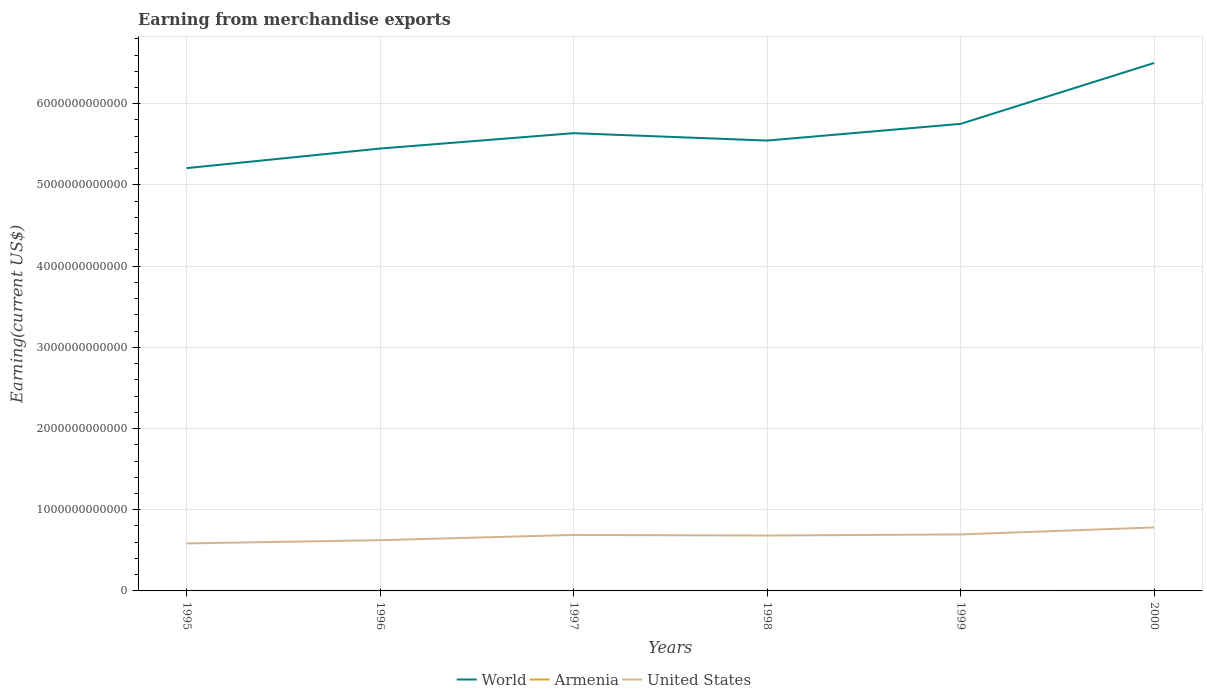Does the line corresponding to World intersect with the line corresponding to United States?
Keep it short and to the point. No. Is the number of lines equal to the number of legend labels?
Provide a succinct answer. Yes. Across all years, what is the maximum amount earned from merchandise exports in United States?
Provide a short and direct response. 5.85e+11. What is the total amount earned from merchandise exports in World in the graph?
Make the answer very short. -7.50e+11. What is the difference between the highest and the second highest amount earned from merchandise exports in World?
Your response must be concise. 1.29e+12. How many lines are there?
Provide a succinct answer. 3. How many years are there in the graph?
Provide a succinct answer. 6. What is the difference between two consecutive major ticks on the Y-axis?
Give a very brief answer. 1.00e+12. Does the graph contain any zero values?
Provide a short and direct response. No. Does the graph contain grids?
Offer a terse response. Yes. How are the legend labels stacked?
Your answer should be very brief. Horizontal. What is the title of the graph?
Your answer should be very brief. Earning from merchandise exports. Does "Comoros" appear as one of the legend labels in the graph?
Make the answer very short. No. What is the label or title of the Y-axis?
Provide a succinct answer. Earning(current US$). What is the Earning(current US$) of World in 1995?
Your response must be concise. 5.21e+12. What is the Earning(current US$) in Armenia in 1995?
Ensure brevity in your answer.  2.71e+08. What is the Earning(current US$) in United States in 1995?
Provide a short and direct response. 5.85e+11. What is the Earning(current US$) in World in 1996?
Give a very brief answer. 5.45e+12. What is the Earning(current US$) in Armenia in 1996?
Your response must be concise. 2.90e+08. What is the Earning(current US$) of United States in 1996?
Your answer should be very brief. 6.25e+11. What is the Earning(current US$) in World in 1997?
Provide a short and direct response. 5.64e+12. What is the Earning(current US$) in Armenia in 1997?
Your response must be concise. 2.33e+08. What is the Earning(current US$) of United States in 1997?
Your answer should be compact. 6.89e+11. What is the Earning(current US$) in World in 1998?
Ensure brevity in your answer.  5.55e+12. What is the Earning(current US$) in Armenia in 1998?
Offer a very short reply. 2.21e+08. What is the Earning(current US$) in United States in 1998?
Your answer should be very brief. 6.82e+11. What is the Earning(current US$) in World in 1999?
Provide a succinct answer. 5.75e+12. What is the Earning(current US$) in Armenia in 1999?
Offer a terse response. 2.32e+08. What is the Earning(current US$) in United States in 1999?
Keep it short and to the point. 6.96e+11. What is the Earning(current US$) of World in 2000?
Ensure brevity in your answer.  6.50e+12. What is the Earning(current US$) in Armenia in 2000?
Your answer should be very brief. 2.94e+08. What is the Earning(current US$) in United States in 2000?
Offer a terse response. 7.82e+11. Across all years, what is the maximum Earning(current US$) of World?
Keep it short and to the point. 6.50e+12. Across all years, what is the maximum Earning(current US$) of Armenia?
Make the answer very short. 2.94e+08. Across all years, what is the maximum Earning(current US$) in United States?
Give a very brief answer. 7.82e+11. Across all years, what is the minimum Earning(current US$) in World?
Provide a short and direct response. 5.21e+12. Across all years, what is the minimum Earning(current US$) in Armenia?
Your answer should be compact. 2.21e+08. Across all years, what is the minimum Earning(current US$) in United States?
Your response must be concise. 5.85e+11. What is the total Earning(current US$) of World in the graph?
Your answer should be compact. 3.41e+13. What is the total Earning(current US$) of Armenia in the graph?
Your answer should be compact. 1.54e+09. What is the total Earning(current US$) of United States in the graph?
Offer a terse response. 4.06e+12. What is the difference between the Earning(current US$) of World in 1995 and that in 1996?
Offer a terse response. -2.41e+11. What is the difference between the Earning(current US$) in Armenia in 1995 and that in 1996?
Ensure brevity in your answer.  -1.90e+07. What is the difference between the Earning(current US$) of United States in 1995 and that in 1996?
Give a very brief answer. -4.03e+1. What is the difference between the Earning(current US$) of World in 1995 and that in 1997?
Your response must be concise. -4.30e+11. What is the difference between the Earning(current US$) of Armenia in 1995 and that in 1997?
Provide a succinct answer. 3.80e+07. What is the difference between the Earning(current US$) in United States in 1995 and that in 1997?
Your answer should be very brief. -1.04e+11. What is the difference between the Earning(current US$) in World in 1995 and that in 1998?
Your answer should be very brief. -3.39e+11. What is the difference between the Earning(current US$) in United States in 1995 and that in 1998?
Offer a terse response. -9.74e+1. What is the difference between the Earning(current US$) in World in 1995 and that in 1999?
Your answer should be compact. -5.45e+11. What is the difference between the Earning(current US$) of Armenia in 1995 and that in 1999?
Keep it short and to the point. 3.90e+07. What is the difference between the Earning(current US$) in United States in 1995 and that in 1999?
Make the answer very short. -1.11e+11. What is the difference between the Earning(current US$) in World in 1995 and that in 2000?
Offer a terse response. -1.29e+12. What is the difference between the Earning(current US$) in Armenia in 1995 and that in 2000?
Offer a terse response. -2.30e+07. What is the difference between the Earning(current US$) in United States in 1995 and that in 2000?
Your answer should be compact. -1.97e+11. What is the difference between the Earning(current US$) of World in 1996 and that in 1997?
Make the answer very short. -1.89e+11. What is the difference between the Earning(current US$) of Armenia in 1996 and that in 1997?
Offer a terse response. 5.70e+07. What is the difference between the Earning(current US$) of United States in 1996 and that in 1997?
Ensure brevity in your answer.  -6.41e+1. What is the difference between the Earning(current US$) of World in 1996 and that in 1998?
Your answer should be very brief. -9.83e+1. What is the difference between the Earning(current US$) in Armenia in 1996 and that in 1998?
Offer a terse response. 6.90e+07. What is the difference between the Earning(current US$) of United States in 1996 and that in 1998?
Your response must be concise. -5.71e+1. What is the difference between the Earning(current US$) in World in 1996 and that in 1999?
Provide a short and direct response. -3.04e+11. What is the difference between the Earning(current US$) in Armenia in 1996 and that in 1999?
Provide a succinct answer. 5.80e+07. What is the difference between the Earning(current US$) of United States in 1996 and that in 1999?
Provide a succinct answer. -7.07e+1. What is the difference between the Earning(current US$) of World in 1996 and that in 2000?
Make the answer very short. -1.05e+12. What is the difference between the Earning(current US$) in United States in 1996 and that in 2000?
Offer a terse response. -1.57e+11. What is the difference between the Earning(current US$) of World in 1997 and that in 1998?
Offer a very short reply. 9.09e+1. What is the difference between the Earning(current US$) in Armenia in 1997 and that in 1998?
Keep it short and to the point. 1.20e+07. What is the difference between the Earning(current US$) of United States in 1997 and that in 1998?
Give a very brief answer. 7.04e+09. What is the difference between the Earning(current US$) in World in 1997 and that in 1999?
Your response must be concise. -1.15e+11. What is the difference between the Earning(current US$) in Armenia in 1997 and that in 1999?
Your answer should be very brief. 1.00e+06. What is the difference between the Earning(current US$) of United States in 1997 and that in 1999?
Your response must be concise. -6.62e+09. What is the difference between the Earning(current US$) in World in 1997 and that in 2000?
Your answer should be very brief. -8.65e+11. What is the difference between the Earning(current US$) in Armenia in 1997 and that in 2000?
Make the answer very short. -6.10e+07. What is the difference between the Earning(current US$) in United States in 1997 and that in 2000?
Make the answer very short. -9.27e+1. What is the difference between the Earning(current US$) in World in 1998 and that in 1999?
Give a very brief answer. -2.06e+11. What is the difference between the Earning(current US$) of Armenia in 1998 and that in 1999?
Provide a succinct answer. -1.10e+07. What is the difference between the Earning(current US$) of United States in 1998 and that in 1999?
Your answer should be very brief. -1.37e+1. What is the difference between the Earning(current US$) in World in 1998 and that in 2000?
Ensure brevity in your answer.  -9.56e+11. What is the difference between the Earning(current US$) of Armenia in 1998 and that in 2000?
Provide a short and direct response. -7.30e+07. What is the difference between the Earning(current US$) of United States in 1998 and that in 2000?
Your response must be concise. -9.98e+1. What is the difference between the Earning(current US$) in World in 1999 and that in 2000?
Offer a terse response. -7.50e+11. What is the difference between the Earning(current US$) of Armenia in 1999 and that in 2000?
Offer a very short reply. -6.20e+07. What is the difference between the Earning(current US$) in United States in 1999 and that in 2000?
Your response must be concise. -8.61e+1. What is the difference between the Earning(current US$) in World in 1995 and the Earning(current US$) in Armenia in 1996?
Make the answer very short. 5.21e+12. What is the difference between the Earning(current US$) in World in 1995 and the Earning(current US$) in United States in 1996?
Make the answer very short. 4.58e+12. What is the difference between the Earning(current US$) in Armenia in 1995 and the Earning(current US$) in United States in 1996?
Your answer should be very brief. -6.25e+11. What is the difference between the Earning(current US$) of World in 1995 and the Earning(current US$) of Armenia in 1997?
Offer a terse response. 5.21e+12. What is the difference between the Earning(current US$) of World in 1995 and the Earning(current US$) of United States in 1997?
Your answer should be very brief. 4.52e+12. What is the difference between the Earning(current US$) in Armenia in 1995 and the Earning(current US$) in United States in 1997?
Keep it short and to the point. -6.89e+11. What is the difference between the Earning(current US$) of World in 1995 and the Earning(current US$) of Armenia in 1998?
Offer a very short reply. 5.21e+12. What is the difference between the Earning(current US$) in World in 1995 and the Earning(current US$) in United States in 1998?
Offer a terse response. 4.52e+12. What is the difference between the Earning(current US$) of Armenia in 1995 and the Earning(current US$) of United States in 1998?
Your answer should be compact. -6.82e+11. What is the difference between the Earning(current US$) of World in 1995 and the Earning(current US$) of Armenia in 1999?
Provide a succinct answer. 5.21e+12. What is the difference between the Earning(current US$) of World in 1995 and the Earning(current US$) of United States in 1999?
Offer a terse response. 4.51e+12. What is the difference between the Earning(current US$) of Armenia in 1995 and the Earning(current US$) of United States in 1999?
Give a very brief answer. -6.96e+11. What is the difference between the Earning(current US$) in World in 1995 and the Earning(current US$) in Armenia in 2000?
Your answer should be very brief. 5.21e+12. What is the difference between the Earning(current US$) in World in 1995 and the Earning(current US$) in United States in 2000?
Give a very brief answer. 4.42e+12. What is the difference between the Earning(current US$) of Armenia in 1995 and the Earning(current US$) of United States in 2000?
Your response must be concise. -7.82e+11. What is the difference between the Earning(current US$) of World in 1996 and the Earning(current US$) of Armenia in 1997?
Keep it short and to the point. 5.45e+12. What is the difference between the Earning(current US$) of World in 1996 and the Earning(current US$) of United States in 1997?
Offer a very short reply. 4.76e+12. What is the difference between the Earning(current US$) of Armenia in 1996 and the Earning(current US$) of United States in 1997?
Offer a very short reply. -6.89e+11. What is the difference between the Earning(current US$) of World in 1996 and the Earning(current US$) of Armenia in 1998?
Keep it short and to the point. 5.45e+12. What is the difference between the Earning(current US$) in World in 1996 and the Earning(current US$) in United States in 1998?
Provide a succinct answer. 4.77e+12. What is the difference between the Earning(current US$) of Armenia in 1996 and the Earning(current US$) of United States in 1998?
Provide a short and direct response. -6.82e+11. What is the difference between the Earning(current US$) in World in 1996 and the Earning(current US$) in Armenia in 1999?
Keep it short and to the point. 5.45e+12. What is the difference between the Earning(current US$) in World in 1996 and the Earning(current US$) in United States in 1999?
Provide a short and direct response. 4.75e+12. What is the difference between the Earning(current US$) of Armenia in 1996 and the Earning(current US$) of United States in 1999?
Make the answer very short. -6.96e+11. What is the difference between the Earning(current US$) of World in 1996 and the Earning(current US$) of Armenia in 2000?
Ensure brevity in your answer.  5.45e+12. What is the difference between the Earning(current US$) in World in 1996 and the Earning(current US$) in United States in 2000?
Your answer should be very brief. 4.67e+12. What is the difference between the Earning(current US$) of Armenia in 1996 and the Earning(current US$) of United States in 2000?
Give a very brief answer. -7.82e+11. What is the difference between the Earning(current US$) of World in 1997 and the Earning(current US$) of Armenia in 1998?
Provide a short and direct response. 5.64e+12. What is the difference between the Earning(current US$) of World in 1997 and the Earning(current US$) of United States in 1998?
Offer a terse response. 4.96e+12. What is the difference between the Earning(current US$) of Armenia in 1997 and the Earning(current US$) of United States in 1998?
Your answer should be compact. -6.82e+11. What is the difference between the Earning(current US$) in World in 1997 and the Earning(current US$) in Armenia in 1999?
Keep it short and to the point. 5.64e+12. What is the difference between the Earning(current US$) of World in 1997 and the Earning(current US$) of United States in 1999?
Your response must be concise. 4.94e+12. What is the difference between the Earning(current US$) of Armenia in 1997 and the Earning(current US$) of United States in 1999?
Provide a short and direct response. -6.96e+11. What is the difference between the Earning(current US$) in World in 1997 and the Earning(current US$) in Armenia in 2000?
Keep it short and to the point. 5.64e+12. What is the difference between the Earning(current US$) of World in 1997 and the Earning(current US$) of United States in 2000?
Offer a terse response. 4.86e+12. What is the difference between the Earning(current US$) of Armenia in 1997 and the Earning(current US$) of United States in 2000?
Offer a very short reply. -7.82e+11. What is the difference between the Earning(current US$) in World in 1998 and the Earning(current US$) in Armenia in 1999?
Your answer should be compact. 5.55e+12. What is the difference between the Earning(current US$) of World in 1998 and the Earning(current US$) of United States in 1999?
Offer a very short reply. 4.85e+12. What is the difference between the Earning(current US$) in Armenia in 1998 and the Earning(current US$) in United States in 1999?
Offer a terse response. -6.96e+11. What is the difference between the Earning(current US$) of World in 1998 and the Earning(current US$) of Armenia in 2000?
Ensure brevity in your answer.  5.55e+12. What is the difference between the Earning(current US$) in World in 1998 and the Earning(current US$) in United States in 2000?
Make the answer very short. 4.76e+12. What is the difference between the Earning(current US$) in Armenia in 1998 and the Earning(current US$) in United States in 2000?
Your answer should be very brief. -7.82e+11. What is the difference between the Earning(current US$) in World in 1999 and the Earning(current US$) in Armenia in 2000?
Your answer should be very brief. 5.75e+12. What is the difference between the Earning(current US$) of World in 1999 and the Earning(current US$) of United States in 2000?
Give a very brief answer. 4.97e+12. What is the difference between the Earning(current US$) of Armenia in 1999 and the Earning(current US$) of United States in 2000?
Give a very brief answer. -7.82e+11. What is the average Earning(current US$) in World per year?
Give a very brief answer. 5.68e+12. What is the average Earning(current US$) in Armenia per year?
Give a very brief answer. 2.57e+08. What is the average Earning(current US$) of United States per year?
Offer a terse response. 6.76e+11. In the year 1995, what is the difference between the Earning(current US$) in World and Earning(current US$) in Armenia?
Give a very brief answer. 5.21e+12. In the year 1995, what is the difference between the Earning(current US$) in World and Earning(current US$) in United States?
Your response must be concise. 4.62e+12. In the year 1995, what is the difference between the Earning(current US$) of Armenia and Earning(current US$) of United States?
Give a very brief answer. -5.84e+11. In the year 1996, what is the difference between the Earning(current US$) in World and Earning(current US$) in Armenia?
Offer a very short reply. 5.45e+12. In the year 1996, what is the difference between the Earning(current US$) of World and Earning(current US$) of United States?
Your answer should be compact. 4.82e+12. In the year 1996, what is the difference between the Earning(current US$) of Armenia and Earning(current US$) of United States?
Make the answer very short. -6.25e+11. In the year 1997, what is the difference between the Earning(current US$) of World and Earning(current US$) of Armenia?
Your response must be concise. 5.64e+12. In the year 1997, what is the difference between the Earning(current US$) in World and Earning(current US$) in United States?
Provide a succinct answer. 4.95e+12. In the year 1997, what is the difference between the Earning(current US$) of Armenia and Earning(current US$) of United States?
Ensure brevity in your answer.  -6.89e+11. In the year 1998, what is the difference between the Earning(current US$) in World and Earning(current US$) in Armenia?
Your answer should be compact. 5.55e+12. In the year 1998, what is the difference between the Earning(current US$) of World and Earning(current US$) of United States?
Your response must be concise. 4.86e+12. In the year 1998, what is the difference between the Earning(current US$) in Armenia and Earning(current US$) in United States?
Give a very brief answer. -6.82e+11. In the year 1999, what is the difference between the Earning(current US$) in World and Earning(current US$) in Armenia?
Your answer should be very brief. 5.75e+12. In the year 1999, what is the difference between the Earning(current US$) in World and Earning(current US$) in United States?
Your answer should be very brief. 5.06e+12. In the year 1999, what is the difference between the Earning(current US$) in Armenia and Earning(current US$) in United States?
Your response must be concise. -6.96e+11. In the year 2000, what is the difference between the Earning(current US$) in World and Earning(current US$) in Armenia?
Offer a terse response. 6.50e+12. In the year 2000, what is the difference between the Earning(current US$) of World and Earning(current US$) of United States?
Make the answer very short. 5.72e+12. In the year 2000, what is the difference between the Earning(current US$) in Armenia and Earning(current US$) in United States?
Provide a succinct answer. -7.82e+11. What is the ratio of the Earning(current US$) of World in 1995 to that in 1996?
Keep it short and to the point. 0.96. What is the ratio of the Earning(current US$) of Armenia in 1995 to that in 1996?
Keep it short and to the point. 0.93. What is the ratio of the Earning(current US$) in United States in 1995 to that in 1996?
Your answer should be compact. 0.94. What is the ratio of the Earning(current US$) of World in 1995 to that in 1997?
Provide a succinct answer. 0.92. What is the ratio of the Earning(current US$) of Armenia in 1995 to that in 1997?
Your response must be concise. 1.16. What is the ratio of the Earning(current US$) of United States in 1995 to that in 1997?
Keep it short and to the point. 0.85. What is the ratio of the Earning(current US$) in World in 1995 to that in 1998?
Provide a short and direct response. 0.94. What is the ratio of the Earning(current US$) in Armenia in 1995 to that in 1998?
Provide a succinct answer. 1.23. What is the ratio of the Earning(current US$) of United States in 1995 to that in 1998?
Your response must be concise. 0.86. What is the ratio of the Earning(current US$) of World in 1995 to that in 1999?
Offer a very short reply. 0.91. What is the ratio of the Earning(current US$) in Armenia in 1995 to that in 1999?
Offer a terse response. 1.17. What is the ratio of the Earning(current US$) of United States in 1995 to that in 1999?
Keep it short and to the point. 0.84. What is the ratio of the Earning(current US$) of World in 1995 to that in 2000?
Make the answer very short. 0.8. What is the ratio of the Earning(current US$) in Armenia in 1995 to that in 2000?
Offer a very short reply. 0.92. What is the ratio of the Earning(current US$) in United States in 1995 to that in 2000?
Ensure brevity in your answer.  0.75. What is the ratio of the Earning(current US$) in World in 1996 to that in 1997?
Give a very brief answer. 0.97. What is the ratio of the Earning(current US$) of Armenia in 1996 to that in 1997?
Provide a short and direct response. 1.24. What is the ratio of the Earning(current US$) of United States in 1996 to that in 1997?
Make the answer very short. 0.91. What is the ratio of the Earning(current US$) in World in 1996 to that in 1998?
Offer a very short reply. 0.98. What is the ratio of the Earning(current US$) in Armenia in 1996 to that in 1998?
Offer a terse response. 1.31. What is the ratio of the Earning(current US$) in United States in 1996 to that in 1998?
Keep it short and to the point. 0.92. What is the ratio of the Earning(current US$) of World in 1996 to that in 1999?
Make the answer very short. 0.95. What is the ratio of the Earning(current US$) of Armenia in 1996 to that in 1999?
Make the answer very short. 1.25. What is the ratio of the Earning(current US$) in United States in 1996 to that in 1999?
Your answer should be very brief. 0.9. What is the ratio of the Earning(current US$) in World in 1996 to that in 2000?
Make the answer very short. 0.84. What is the ratio of the Earning(current US$) of Armenia in 1996 to that in 2000?
Ensure brevity in your answer.  0.99. What is the ratio of the Earning(current US$) of United States in 1996 to that in 2000?
Your response must be concise. 0.8. What is the ratio of the Earning(current US$) of World in 1997 to that in 1998?
Keep it short and to the point. 1.02. What is the ratio of the Earning(current US$) in Armenia in 1997 to that in 1998?
Provide a succinct answer. 1.05. What is the ratio of the Earning(current US$) in United States in 1997 to that in 1998?
Keep it short and to the point. 1.01. What is the ratio of the Earning(current US$) of World in 1997 to that in 1999?
Ensure brevity in your answer.  0.98. What is the ratio of the Earning(current US$) of World in 1997 to that in 2000?
Ensure brevity in your answer.  0.87. What is the ratio of the Earning(current US$) in Armenia in 1997 to that in 2000?
Your response must be concise. 0.79. What is the ratio of the Earning(current US$) in United States in 1997 to that in 2000?
Provide a short and direct response. 0.88. What is the ratio of the Earning(current US$) in World in 1998 to that in 1999?
Provide a short and direct response. 0.96. What is the ratio of the Earning(current US$) in Armenia in 1998 to that in 1999?
Offer a very short reply. 0.95. What is the ratio of the Earning(current US$) of United States in 1998 to that in 1999?
Offer a terse response. 0.98. What is the ratio of the Earning(current US$) of World in 1998 to that in 2000?
Offer a very short reply. 0.85. What is the ratio of the Earning(current US$) in Armenia in 1998 to that in 2000?
Your answer should be very brief. 0.75. What is the ratio of the Earning(current US$) of United States in 1998 to that in 2000?
Your response must be concise. 0.87. What is the ratio of the Earning(current US$) of World in 1999 to that in 2000?
Offer a terse response. 0.88. What is the ratio of the Earning(current US$) of Armenia in 1999 to that in 2000?
Offer a terse response. 0.79. What is the ratio of the Earning(current US$) of United States in 1999 to that in 2000?
Your response must be concise. 0.89. What is the difference between the highest and the second highest Earning(current US$) of World?
Provide a succinct answer. 7.50e+11. What is the difference between the highest and the second highest Earning(current US$) in United States?
Your answer should be compact. 8.61e+1. What is the difference between the highest and the lowest Earning(current US$) of World?
Your answer should be compact. 1.29e+12. What is the difference between the highest and the lowest Earning(current US$) of Armenia?
Your answer should be very brief. 7.30e+07. What is the difference between the highest and the lowest Earning(current US$) of United States?
Keep it short and to the point. 1.97e+11. 